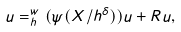Convert formula to latex. <formula><loc_0><loc_0><loc_500><loc_500>u = _ { h } ^ { w } ( \psi ( X / h ^ { \delta } ) ) u + R u ,</formula> 